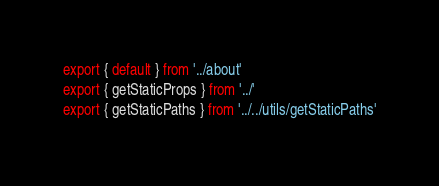<code> <loc_0><loc_0><loc_500><loc_500><_TypeScript_>export { default } from '../about'
export { getStaticProps } from '../'
export { getStaticPaths } from '../../utils/getStaticPaths'
</code> 